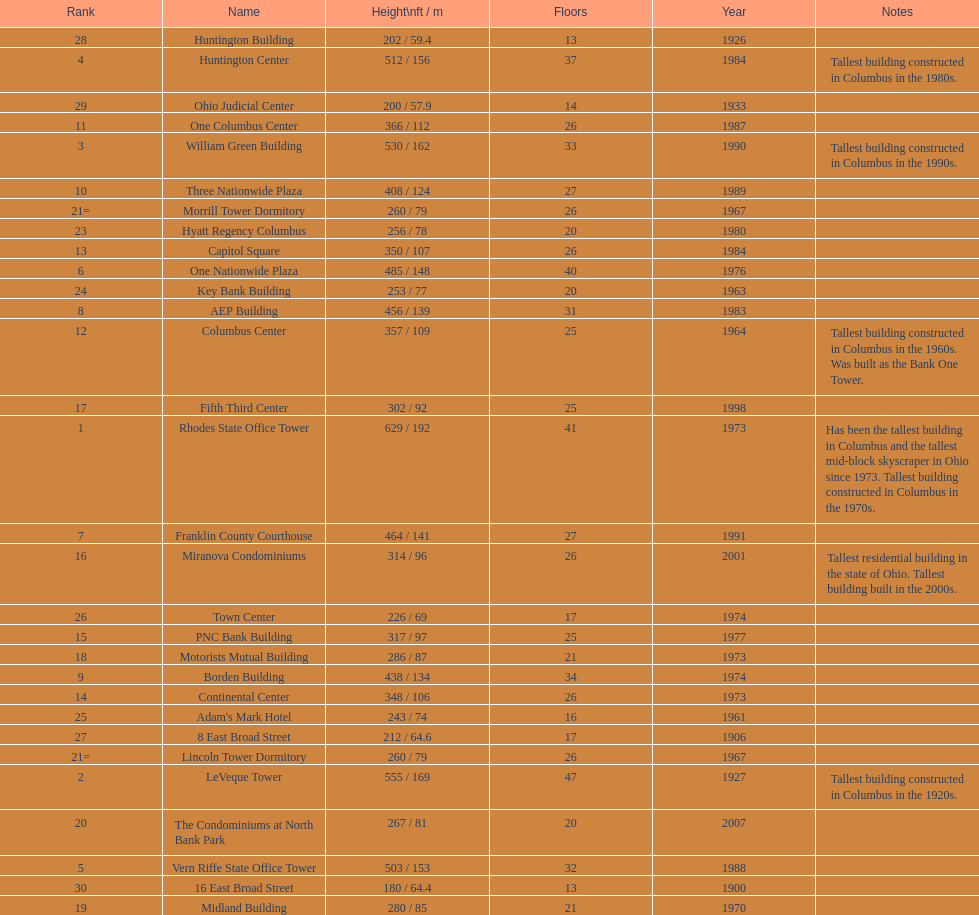Which is taller, the aep building or the one columbus center? AEP Building. 